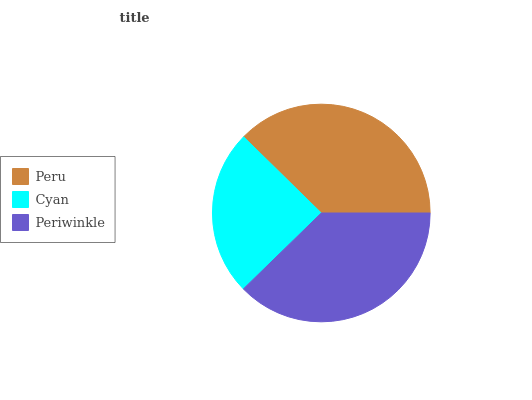Is Cyan the minimum?
Answer yes or no. Yes. Is Periwinkle the maximum?
Answer yes or no. Yes. Is Periwinkle the minimum?
Answer yes or no. No. Is Cyan the maximum?
Answer yes or no. No. Is Periwinkle greater than Cyan?
Answer yes or no. Yes. Is Cyan less than Periwinkle?
Answer yes or no. Yes. Is Cyan greater than Periwinkle?
Answer yes or no. No. Is Periwinkle less than Cyan?
Answer yes or no. No. Is Peru the high median?
Answer yes or no. Yes. Is Peru the low median?
Answer yes or no. Yes. Is Cyan the high median?
Answer yes or no. No. Is Periwinkle the low median?
Answer yes or no. No. 